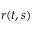Convert formula to latex. <formula><loc_0><loc_0><loc_500><loc_500>{ r } ( t , s )</formula> 